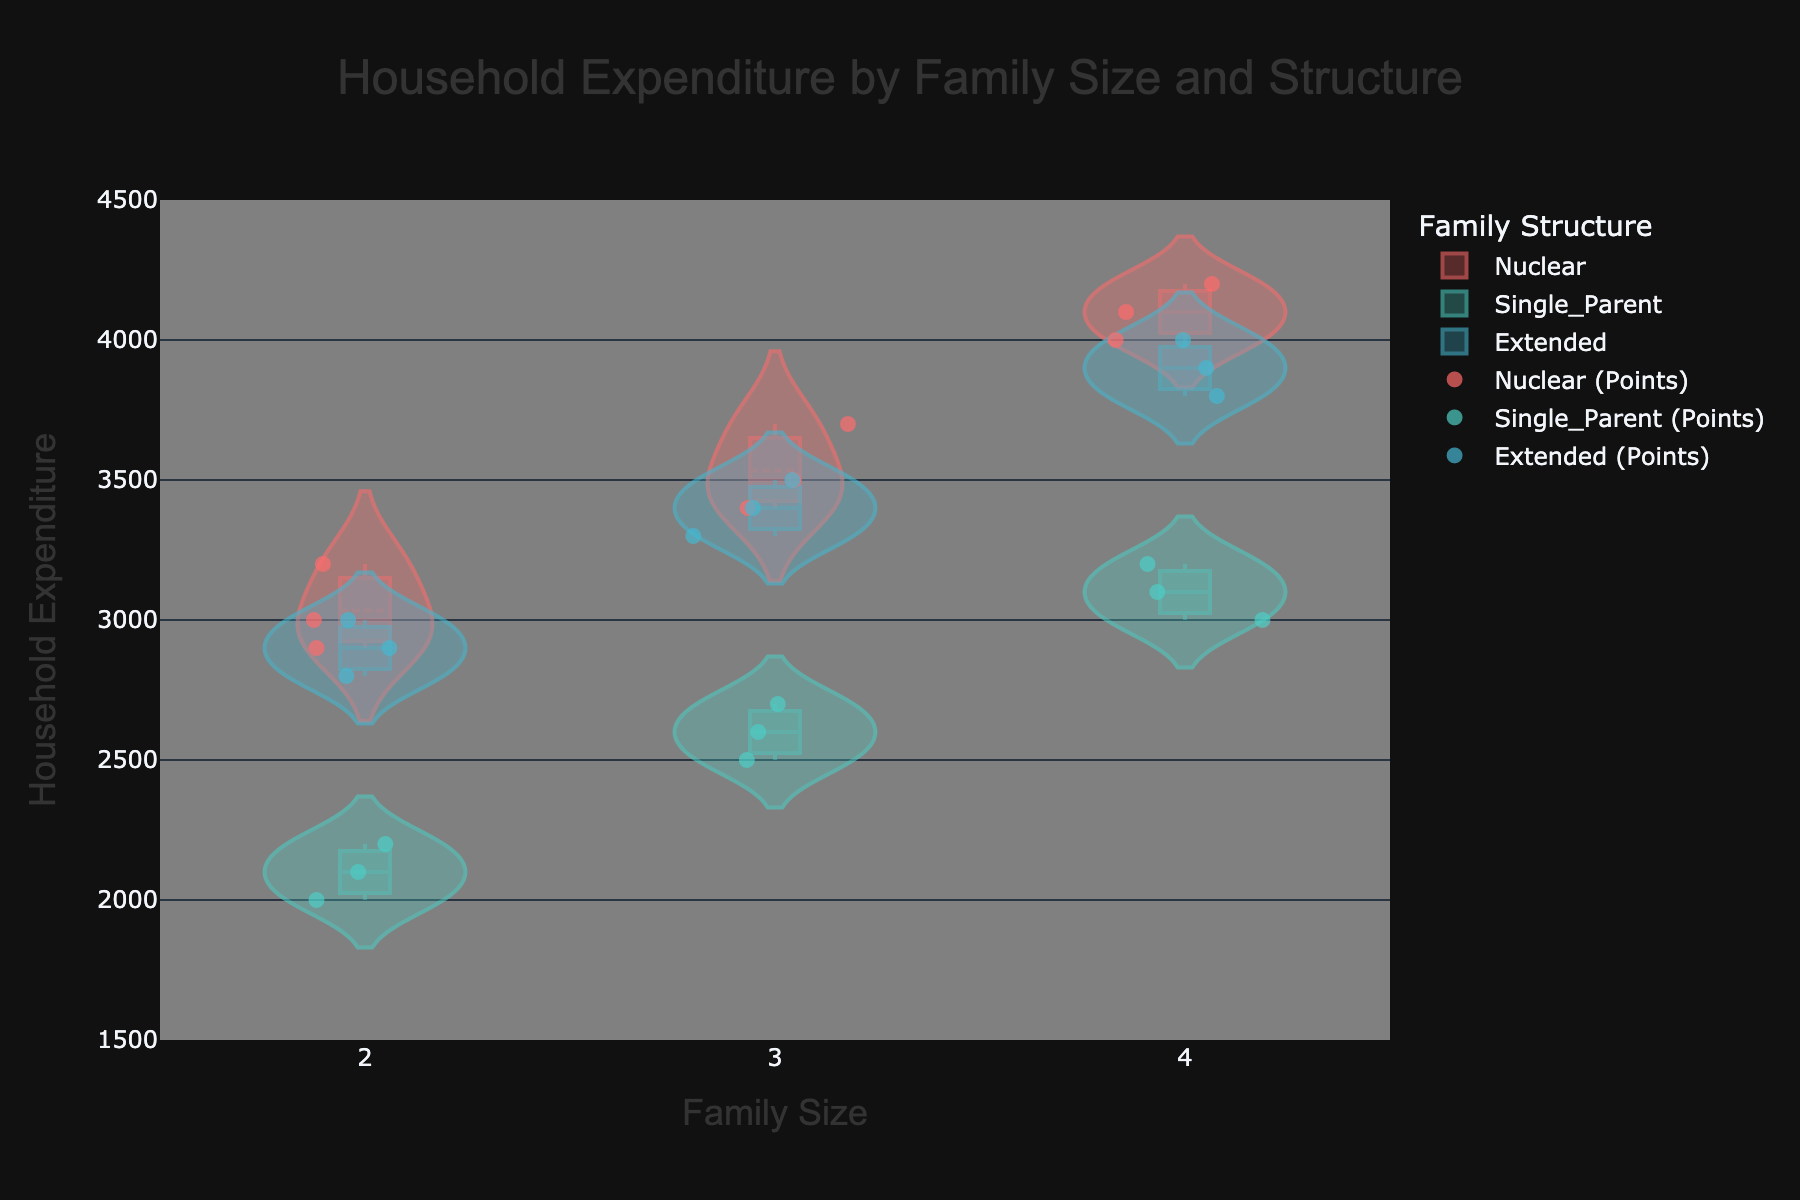What's the title of the figure? The title is displayed at the top center of the figure. It usually describes what the figure is about.
Answer: Household Expenditure by Family Size and Structure What family sizes are represented on the x-axis? The x-axis is labeled with family sizes. By examining the x-axis ticks or labels, we can determine the family sizes shown.
Answer: 2, 3, 4 Which family structure has the highest average expenditure for family size 4? To determine this, we need to observe the mean lines and their positions in the violin plots for family size 4. The highest mean line will indicate the highest average.
Answer: Nuclear Which family structure has the lowest expenditure for family size 2? To determine the lowest expenditure, examine the points and the lower bound of the violin plots for family size 2. The lowest point within a family structure represents the minimum expenditure.
Answer: Single_Parent How does household expenditure generally change as family size increases for Nuclear families? Observing the violin plots for Nuclear families across different family sizes, determining whether expenditures increase, decrease, or remain stable can be identified by the trend in median or mean lines.
Answer: Increases What are the box plots used for in the violin charts? Observing the individual violin charts, the box plots within them typically represent the interquartile range, showing the spread of data around the median.
Answer: Interquartile range Which family structure has the most dispersed household expenditures for family size 3? The dispersion in a violin plot can be observed by looking at the width of the plot and the spread of data points for family size 3. The wider or more spread out the points, the more dispersed the expenditures are.
Answer: Single_Parent Comparing Single_Parent and Extended families, which has more variability in household expenditure for family size 4? Variability in expenditure can be determined by comparing the spread of the violin plots and the scatter points for both family structures at family size 4.
Answer: Extended What can we say about the expenditure of Nuclear and Extended families for family size 3 in terms of median? To compare medians, one can look at the middle line in the box plots within the violin charts for both family structures of family size 3.
Answer: Nuclear family has a higher median expenditure For family size 2, which family structure shows higher maximum household expenditures? Maximum expenditures are observed by identifying the highest points in the violin plots or scatter points for family size 2 across different family structures.
Answer: Nuclear 